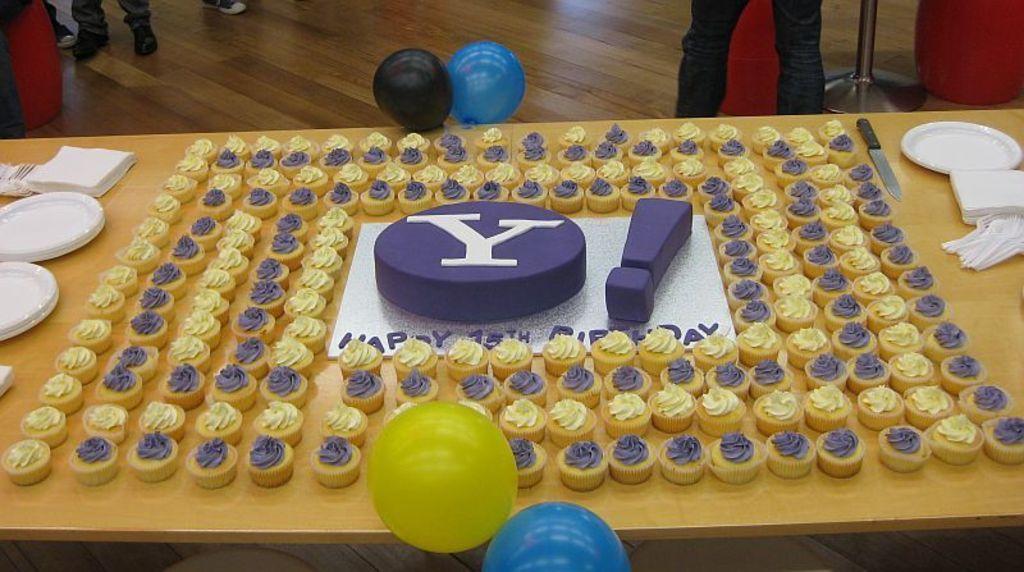In one or two sentences, can you explain what this image depicts? We can see group of cakes,plates,tissue papers,knife,balloons on the table and we can see persons ,stand on the floor. 